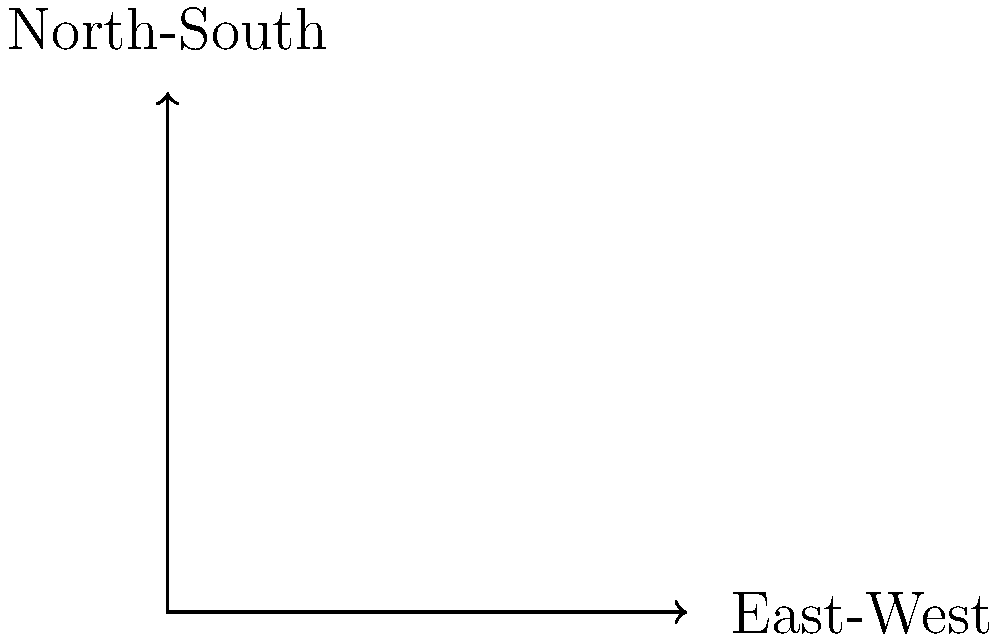As a local politician working with community leaders to address issues faced by the Indian diaspora, you're tasked with improving traffic flow at a key intersection. The diagram shows the traffic volumes (in vehicles per hour) for each direction. Based on this information, which approach should be given priority for green time in the traffic signal timing plan to minimize overall delays? To determine the optimal traffic signal timing and prioritize green time, we need to analyze the traffic flow patterns:

1. Identify the traffic volumes for each approach:
   - Northbound: 800 vph (vehicles per hour)
   - Southbound: 600 vph
   - Eastbound: 500 vph
   - Westbound: 400 vph

2. Calculate the total volume for each direction:
   - North-South: 800 + 600 = 1400 vph
   - East-West: 500 + 400 = 900 vph

3. Compare the total volumes:
   The North-South direction has a higher total volume (1400 vph) compared to the East-West direction (900 vph).

4. Consider the impact on the community:
   As a local politician addressing issues faced by the Indian diaspora, it's important to prioritize the direction that serves the majority of the community while also considering overall traffic efficiency.

5. Determine the priority:
   Given that the North-South direction has a significantly higher traffic volume, prioritizing this direction for green time would likely result in minimizing overall delays for the majority of drivers, including members of the Indian diaspora community.

6. Recommend signal timing strategy:
   Allocate a longer green time for the North-South direction while ensuring sufficient time for the East-West direction to prevent excessive queuing.

By prioritizing the North-South direction, we can potentially reduce wait times and congestion for the larger volume of traffic, which would benefit the overall community, including the Indian diaspora.
Answer: North-South direction 